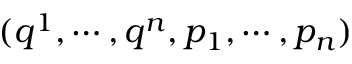Convert formula to latex. <formula><loc_0><loc_0><loc_500><loc_500>( q ^ { 1 } , \cdots , q ^ { n } , p _ { 1 } , \cdots , p _ { n } )</formula> 